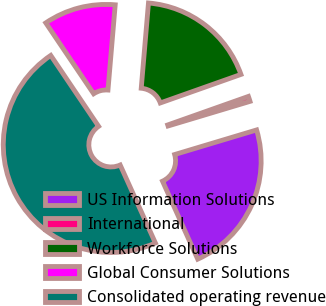Convert chart to OTSL. <chart><loc_0><loc_0><loc_500><loc_500><pie_chart><fcel>US Information Solutions<fcel>International<fcel>Workforce Solutions<fcel>Global Consumer Solutions<fcel>Consolidated operating revenue<nl><fcel>22.89%<fcel>0.77%<fcel>18.24%<fcel>10.8%<fcel>47.3%<nl></chart> 